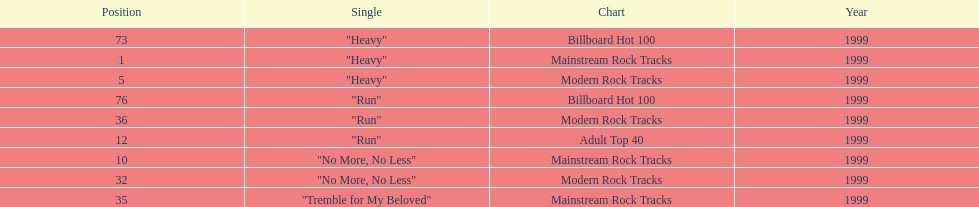Which of the singles from "dosage" had the highest billboard hot 100 rating? "Heavy". 